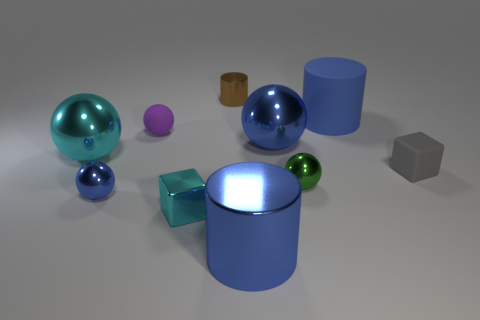How many other things are there of the same color as the big matte cylinder?
Provide a short and direct response. 3. What color is the large metallic object that is both behind the tiny cyan thing and to the right of the small purple matte thing?
Offer a terse response. Blue. There is another object that is the same shape as the small cyan metal object; what is it made of?
Offer a terse response. Rubber. Are there any other things that have the same size as the brown object?
Your answer should be compact. Yes. Is the number of green objects greater than the number of big blue metal cubes?
Give a very brief answer. Yes. What is the size of the ball that is both behind the gray thing and to the left of the tiny purple matte sphere?
Ensure brevity in your answer.  Large. There is a purple rubber object; what shape is it?
Your answer should be very brief. Sphere. How many blue matte objects are the same shape as the small brown shiny object?
Offer a very short reply. 1. Is the number of small purple rubber balls that are in front of the large blue metallic cylinder less than the number of large metal objects behind the brown cylinder?
Offer a terse response. No. What number of purple rubber spheres are to the left of the tiny cube left of the small rubber block?
Ensure brevity in your answer.  1. 